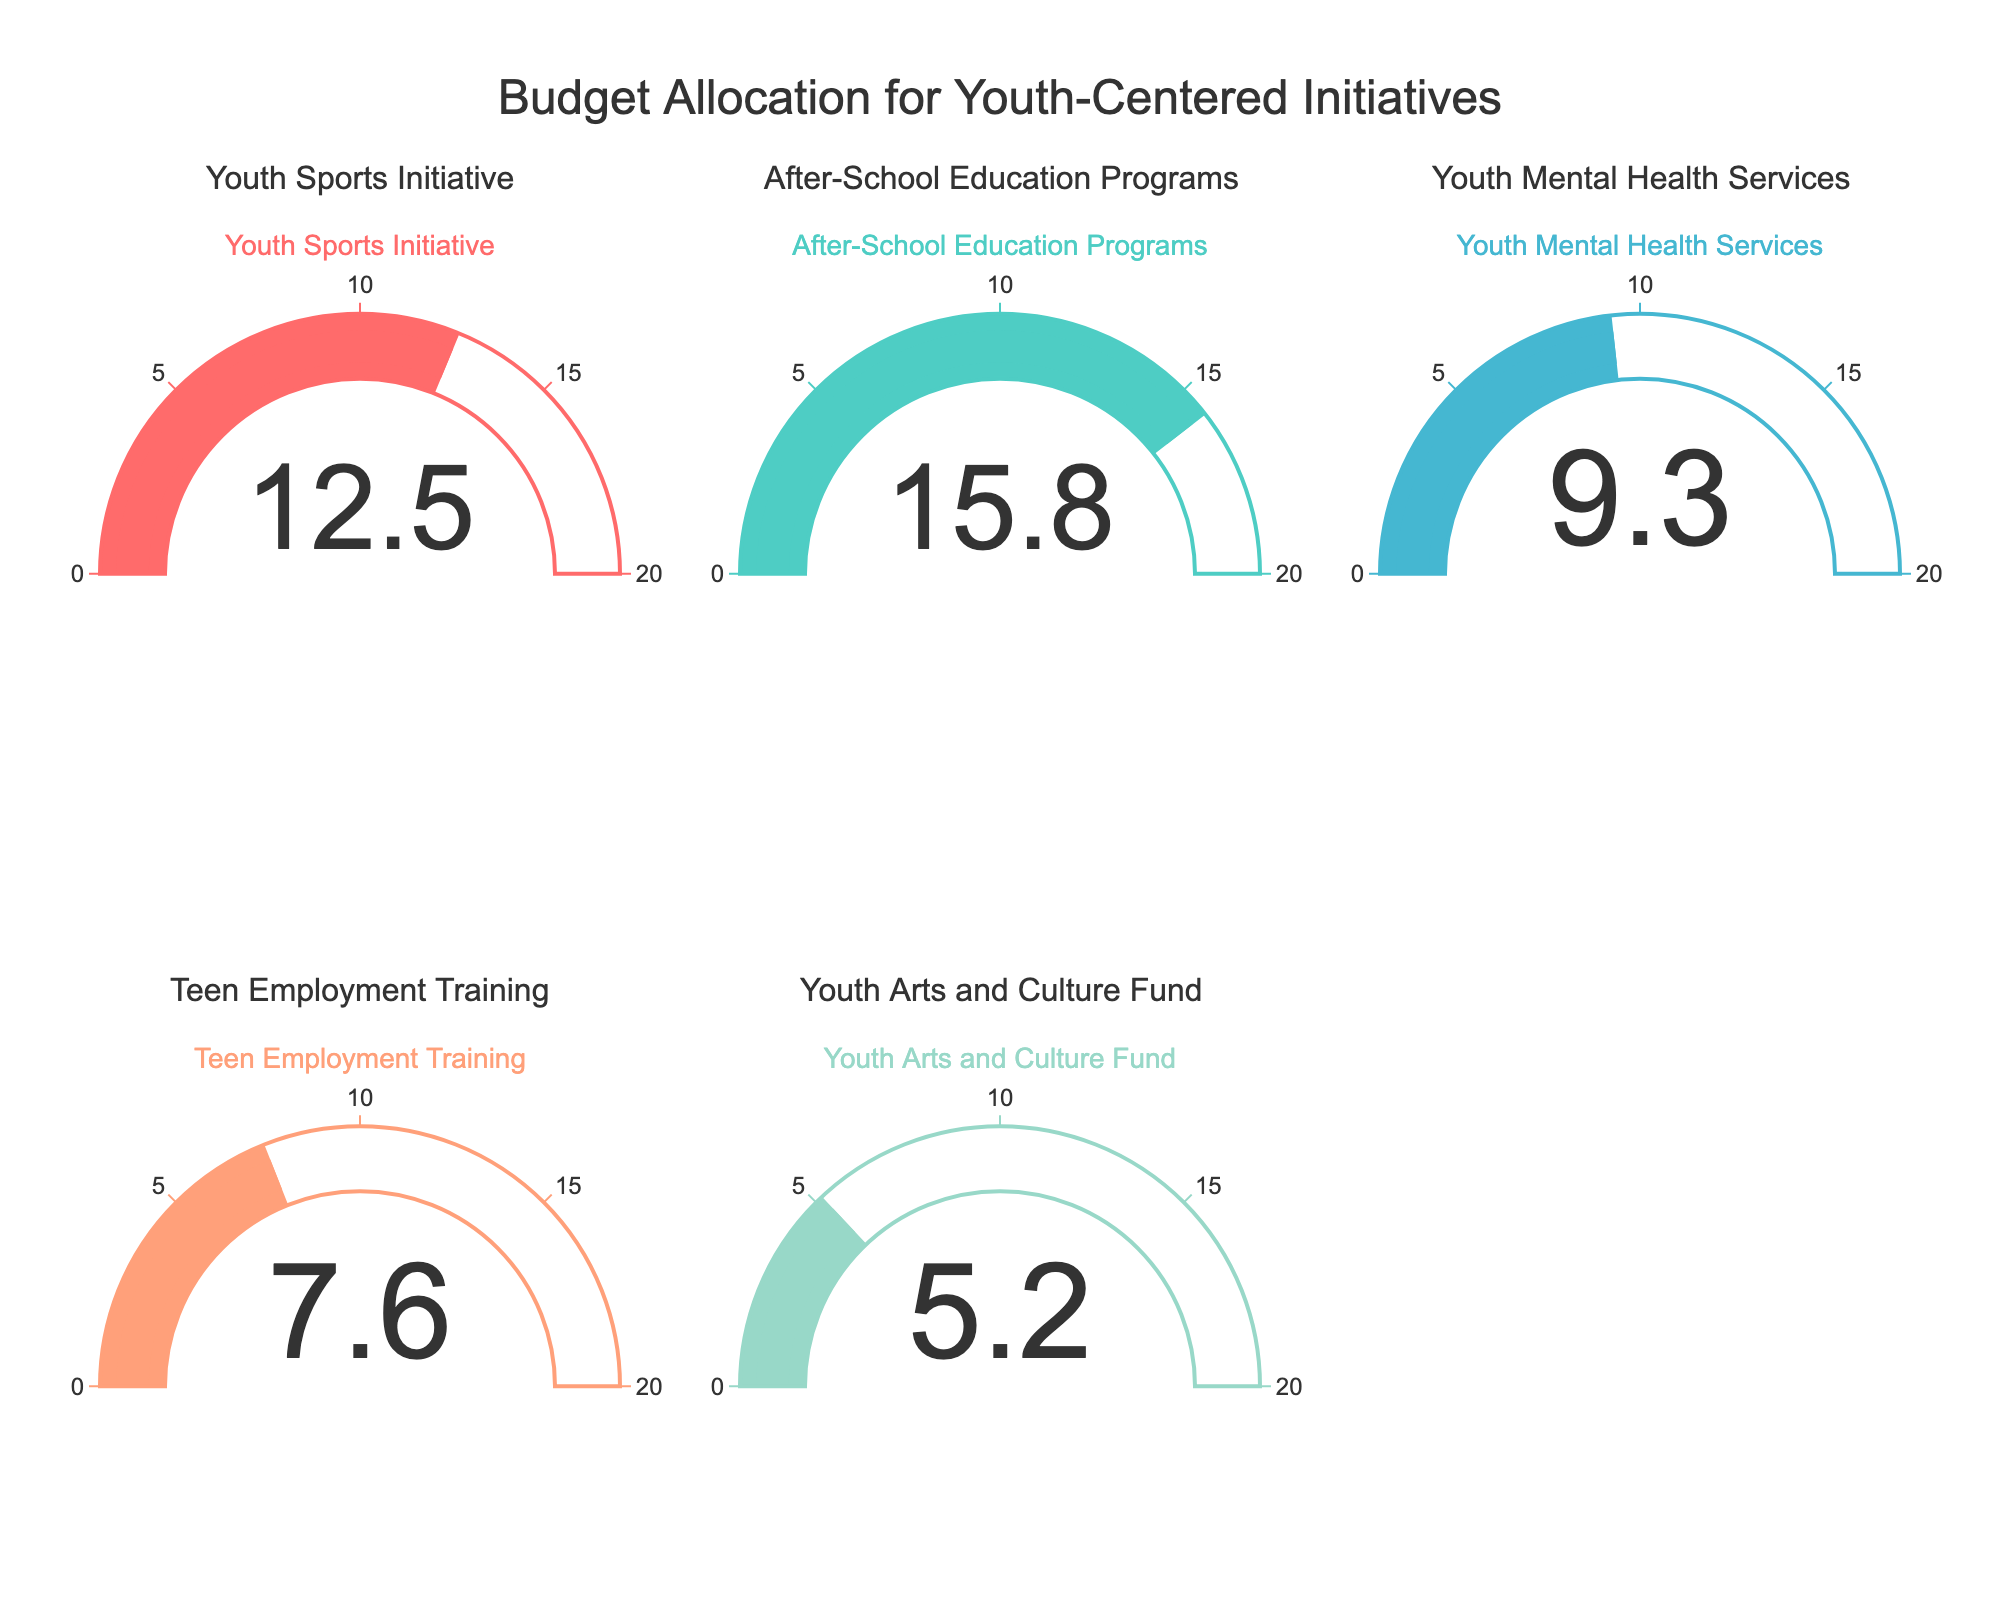What is the percentage of budget allocated to the Teen Employment Training program? The percentage of budget allocated to the Teen Employment Training program is displayed on the gauge chart corresponding to that program.
Answer: 7.6% What is the highest budget percentage allocated to any youth-centered initiative? Compare the gauge values for all programs to find the highest percentage value.
Answer: 15.8% What is the total percentage of budget allocated to the Youth Sports Initiative and Youth Arts and Culture Fund combined? Add the budget percentages for the Youth Sports Initiative (12.5%) and Youth Arts and Culture Fund (5.2%): 12.5 + 5.2 = 17.7
Answer: 17.7% How much more percentage of budget is allocated to After-School Education Programs compared to Youth Mental Health Services? Subtract the budget percentage of Youth Mental Health Services (9.3%) from After-School Education Programs (15.8%): 15.8 - 9.3 = 6.5
Answer: 6.5% Which program has the lowest percentage of budget allocation? Compare the gauge values for all programs to find the lowest percentage value.
Answer: Youth Arts and Culture Fund Does any program have a budget allocation percentage in the range of 10% to 20%? Check the gauge values for all programs to see if any of them fall within the 10% to 20% range. Both Youth Sports Initiative and After-School Programs fall in this range.
Answer: Yes What is the average percentage of budget allocated across all the youth-centered initiatives? Sum all the percentages and divide by the number of programs (5): (12.5 + 15.8 + 9.3 + 7.6 + 5.2) / 5 = 10.08
Answer: 10.08% What percentage of the budget is allocated to the Youth Mental Health Services? The gauge chart indicates the percentage of budget allocated to Youth Mental Health Services.
Answer: 9.3% If the budget for the Youth Arts and Culture Fund was increased by 50%, what would be the new percentage allocation? Increase the current percentage by 50% and add to the original: 5.2 * 0.50 = 2.6, so 5.2 + 2.6 = 7.8
Answer: 7.8% 